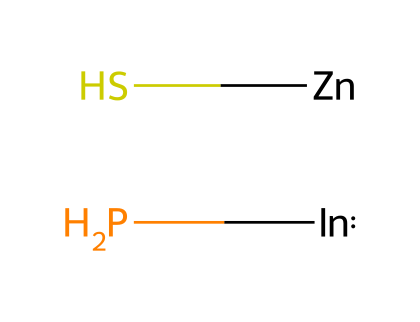What elements are present in this quantum dot? The SMILES representation [In]P.[Zn]S indicates that the compound consists of indium (In), phosphorus (P), zinc (Zn), and sulfur (S). Each element is explicitly mentioned in the SMILES notation.
Answer: indium, phosphorus, zinc, sulfur How many total atoms are in this quantum dot? The SMILES shows four distinct elements: indium, phosphorus, zinc, and sulfur. Counting these gives a total of four atoms.
Answer: four What is the core-shell structure in this quantum dot? In this case, indium phosphide forms the core, while zinc sulfide constitutes the shell around it, creating a protective and stabilizing layer.
Answer: indium phosphide core, zinc sulfide shell What is the significance of the core-shell configuration? The core-shell configuration enhances photostability and reduces non-radiative recombination, making it vital for applications in optoelectronics and biomedicine.
Answer: enhances photostability How does the bandgap of this quantum dot compare to its elements? The quantum dot's bandgap is influenced by the individual bandgaps of indium phosphide and zinc sulfide, typically resulting in a tunable range based on the core-shell combination.
Answer: tunable bandgap What is the expected application of indium phosphide/zinc sulfide quantum dots? These quantum dots are commonly used in applications like displays, imaging, and solar cells due to their unique optical properties.
Answer: displays, imaging, solar cells 